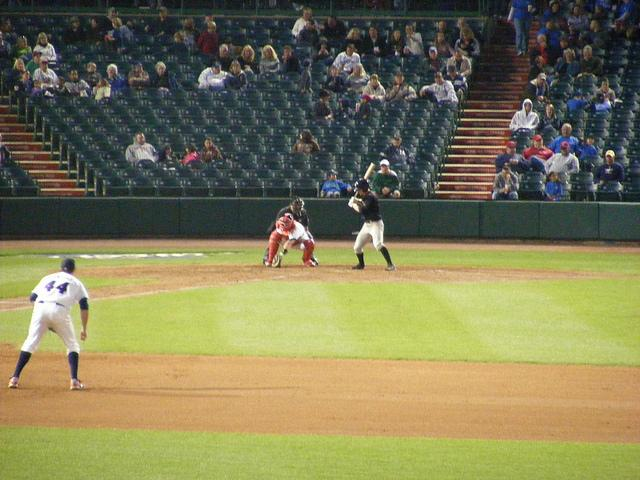How does the temperature likely feel? cool 